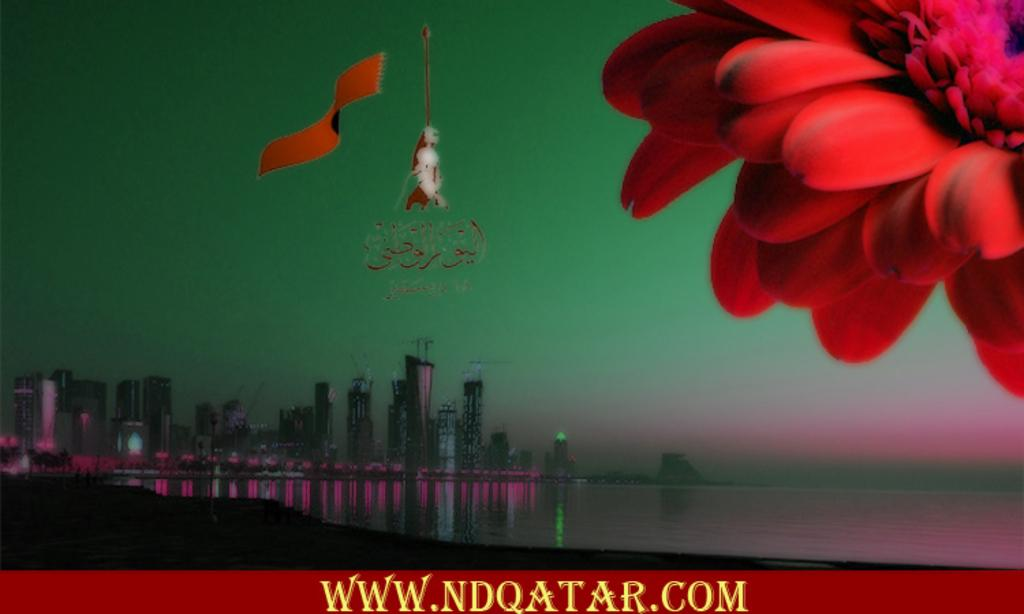What is the main feature of the image? There is an ocean in the image. What else can be seen in the image besides the ocean? There are buildings in the image. Is there any specific object or detail in the top right corner of the image? Yes, there is a red color flower in the top right corner of the image. Can you describe any additional elements present in the image? There is a watermark in the bottom part of the image. Where is the harbor located in the image? There is no harbor present in the image; it only features an ocean, buildings, a red flower, and a watermark. Can you see any volcanoes in the image? No, there are no volcanoes visible in the image. 